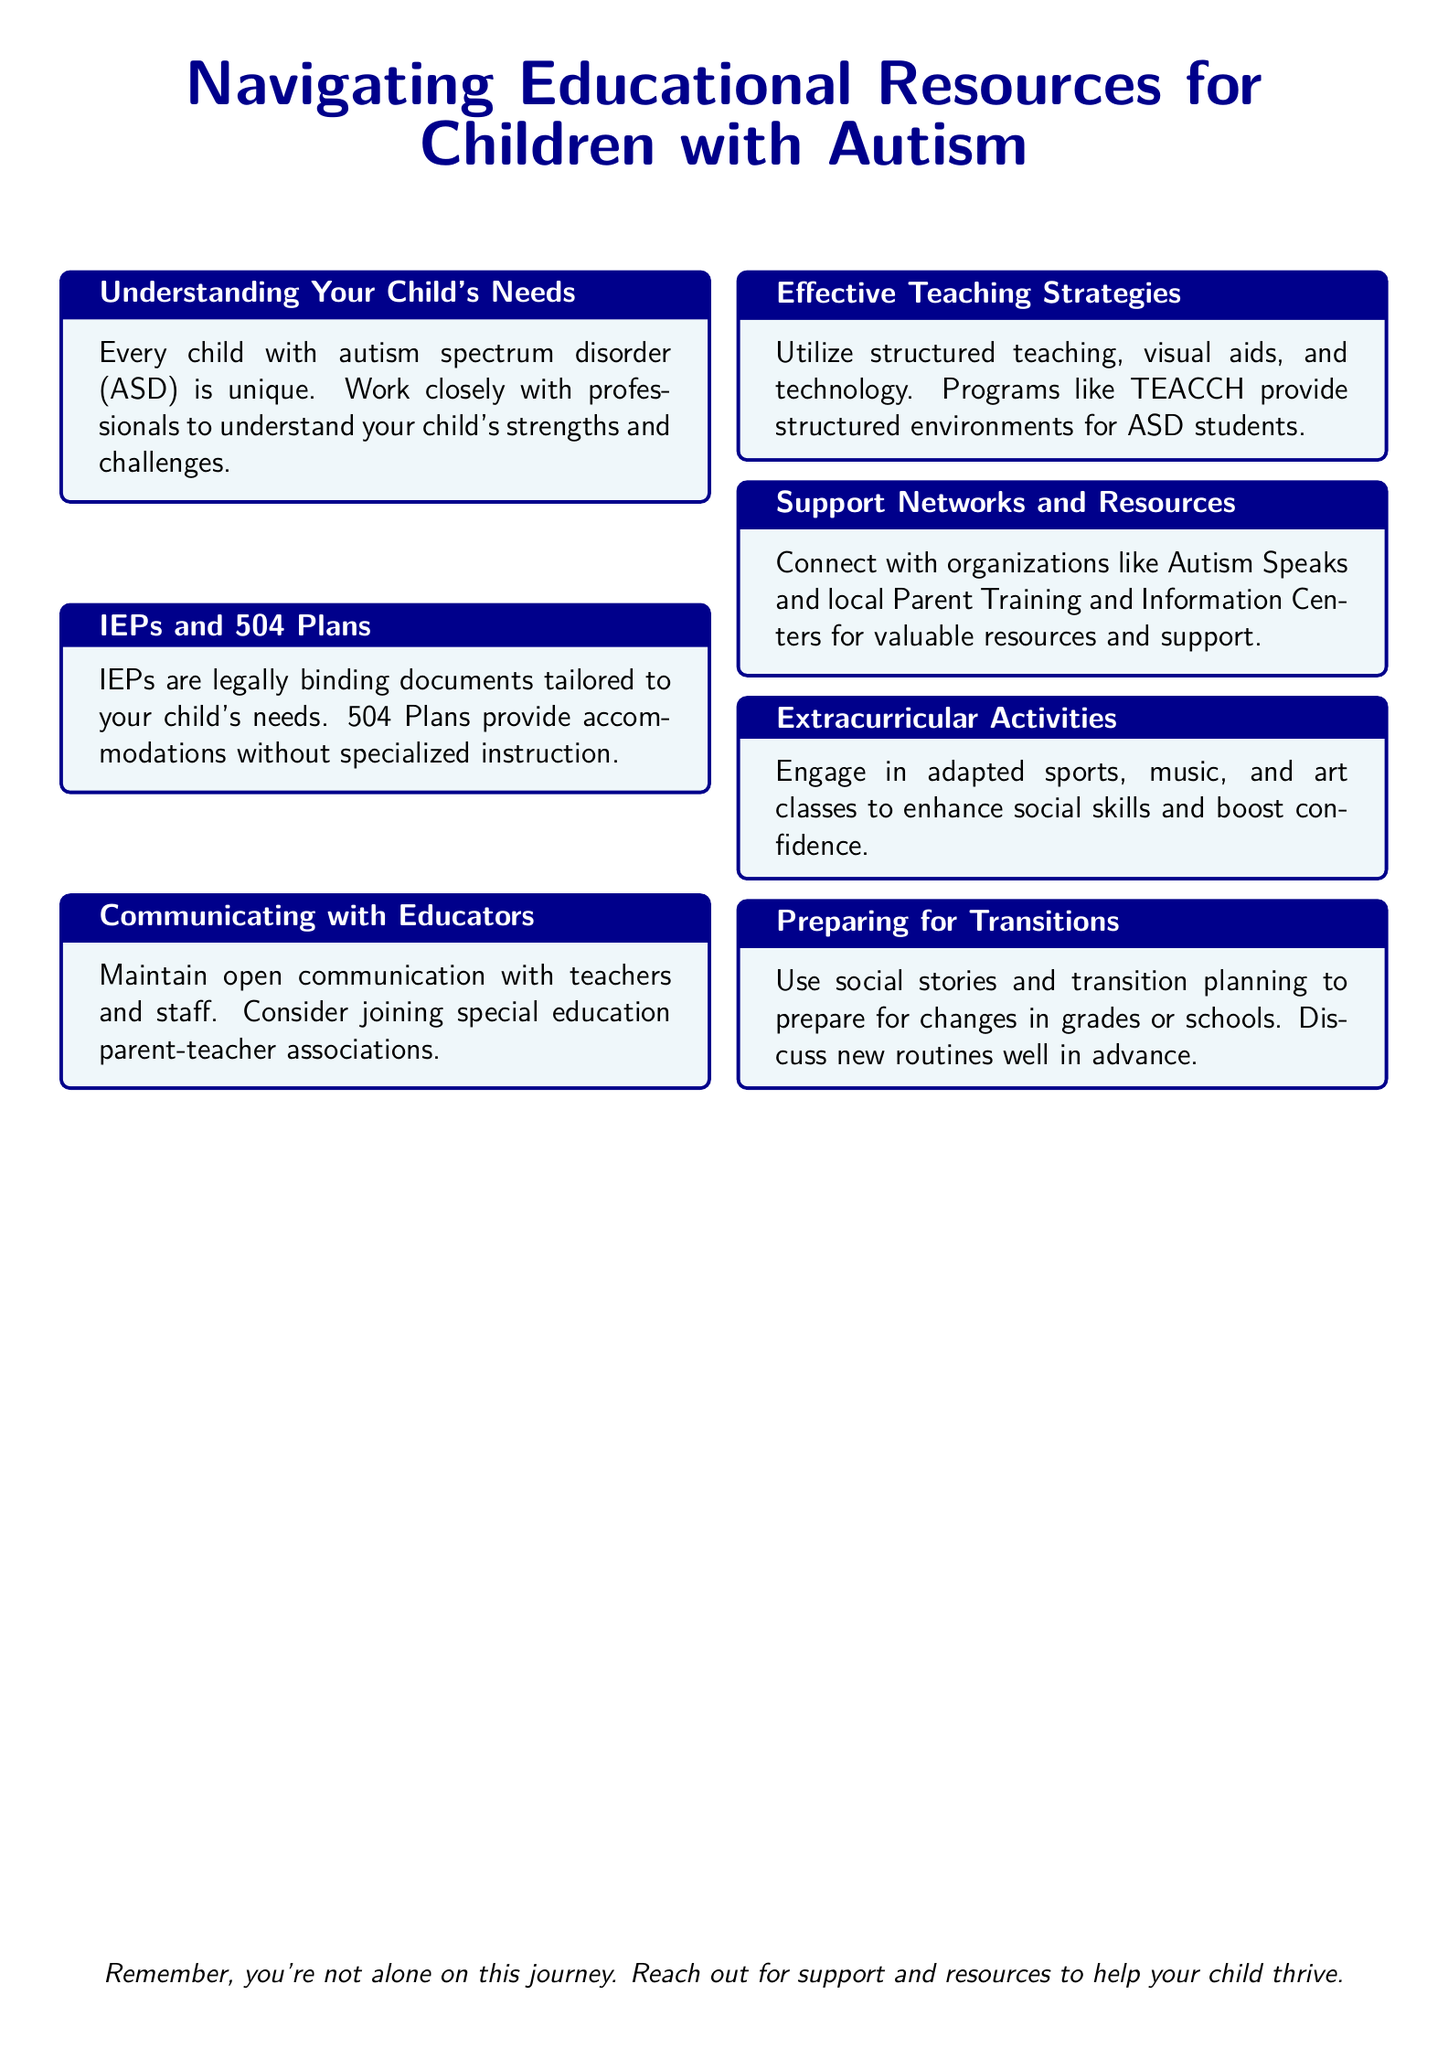What is the title of the document? The title is prominently displayed at the top of the document and is "Navigating Educational Resources for Children with Autism."
Answer: Navigating Educational Resources for Children with Autism What are IEPs? The document defines IEPs as legally binding documents tailored to a child's needs.
Answer: Legally binding documents Which organization is mentioned for valuable resources? The document refers to "Autism Speaks" as an organization for valuable resources.
Answer: Autism Speaks What type of plans provide accommodations without specialized instruction? The document states that 504 Plans provide accommodations without specialized instruction.
Answer: 504 Plans What teaching strategy is recommended in the document? The document suggests utilizing structured teaching as an effective strategy.
Answer: Structured teaching What should be used to prepare for transitions? The document advises using social stories to prepare for transitions.
Answer: Social stories How many sections are there in the document? There are a total of 7 sections in the document.
Answer: 7 Which additional classes are suggested for enhancing social skills? The document mentions engaging in adapted sports, music, and art classes.
Answer: Adapted sports, music, and art classes What is recommended for maintaining communication with educators? The document emphasizes maintaining open communication with teachers and staff.
Answer: Open communication 